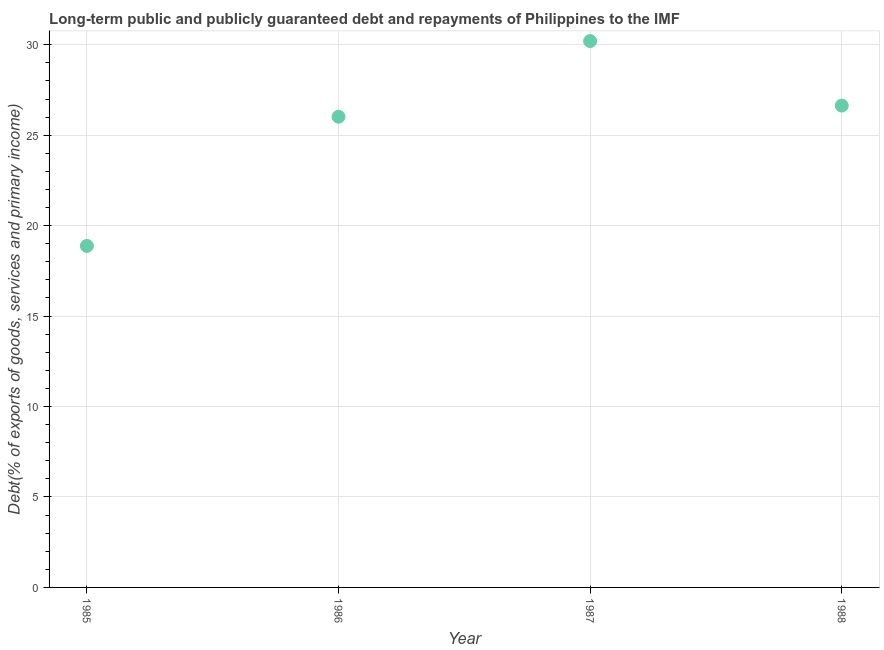What is the debt service in 1985?
Offer a terse response. 18.88. Across all years, what is the maximum debt service?
Offer a very short reply. 30.2. Across all years, what is the minimum debt service?
Keep it short and to the point. 18.88. In which year was the debt service minimum?
Give a very brief answer. 1985. What is the sum of the debt service?
Your answer should be very brief. 101.74. What is the difference between the debt service in 1986 and 1987?
Make the answer very short. -4.18. What is the average debt service per year?
Give a very brief answer. 25.43. What is the median debt service?
Give a very brief answer. 26.33. In how many years, is the debt service greater than 25 %?
Keep it short and to the point. 3. Do a majority of the years between 1986 and 1987 (inclusive) have debt service greater than 22 %?
Offer a terse response. Yes. What is the ratio of the debt service in 1985 to that in 1987?
Ensure brevity in your answer.  0.63. Is the difference between the debt service in 1985 and 1988 greater than the difference between any two years?
Offer a very short reply. No. What is the difference between the highest and the second highest debt service?
Keep it short and to the point. 3.57. What is the difference between the highest and the lowest debt service?
Your answer should be very brief. 11.32. How many dotlines are there?
Offer a terse response. 1. Does the graph contain any zero values?
Keep it short and to the point. No. What is the title of the graph?
Provide a short and direct response. Long-term public and publicly guaranteed debt and repayments of Philippines to the IMF. What is the label or title of the Y-axis?
Your answer should be compact. Debt(% of exports of goods, services and primary income). What is the Debt(% of exports of goods, services and primary income) in 1985?
Provide a short and direct response. 18.88. What is the Debt(% of exports of goods, services and primary income) in 1986?
Your answer should be compact. 26.02. What is the Debt(% of exports of goods, services and primary income) in 1987?
Your response must be concise. 30.2. What is the Debt(% of exports of goods, services and primary income) in 1988?
Give a very brief answer. 26.64. What is the difference between the Debt(% of exports of goods, services and primary income) in 1985 and 1986?
Your answer should be compact. -7.14. What is the difference between the Debt(% of exports of goods, services and primary income) in 1985 and 1987?
Give a very brief answer. -11.32. What is the difference between the Debt(% of exports of goods, services and primary income) in 1985 and 1988?
Offer a terse response. -7.76. What is the difference between the Debt(% of exports of goods, services and primary income) in 1986 and 1987?
Provide a short and direct response. -4.18. What is the difference between the Debt(% of exports of goods, services and primary income) in 1986 and 1988?
Offer a terse response. -0.62. What is the difference between the Debt(% of exports of goods, services and primary income) in 1987 and 1988?
Give a very brief answer. 3.57. What is the ratio of the Debt(% of exports of goods, services and primary income) in 1985 to that in 1986?
Your response must be concise. 0.73. What is the ratio of the Debt(% of exports of goods, services and primary income) in 1985 to that in 1988?
Your answer should be compact. 0.71. What is the ratio of the Debt(% of exports of goods, services and primary income) in 1986 to that in 1987?
Give a very brief answer. 0.86. What is the ratio of the Debt(% of exports of goods, services and primary income) in 1987 to that in 1988?
Your answer should be compact. 1.13. 